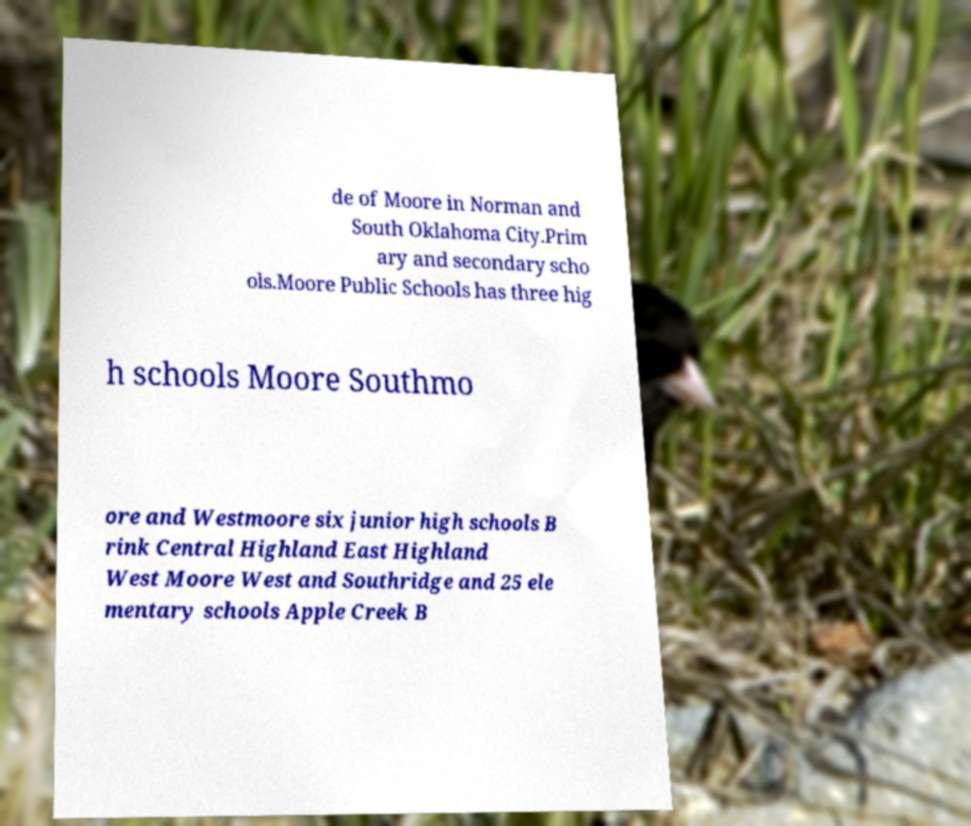Please identify and transcribe the text found in this image. de of Moore in Norman and South Oklahoma City.Prim ary and secondary scho ols.Moore Public Schools has three hig h schools Moore Southmo ore and Westmoore six junior high schools B rink Central Highland East Highland West Moore West and Southridge and 25 ele mentary schools Apple Creek B 